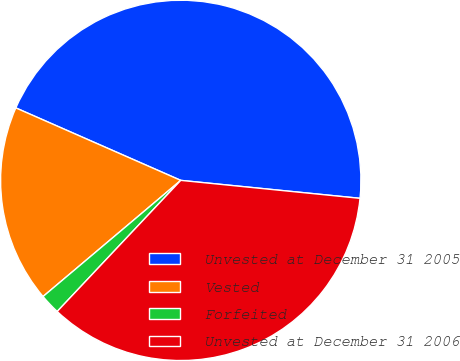Convert chart. <chart><loc_0><loc_0><loc_500><loc_500><pie_chart><fcel>Unvested at December 31 2005<fcel>Vested<fcel>Forfeited<fcel>Unvested at December 31 2006<nl><fcel>45.0%<fcel>17.74%<fcel>1.82%<fcel>35.44%<nl></chart> 